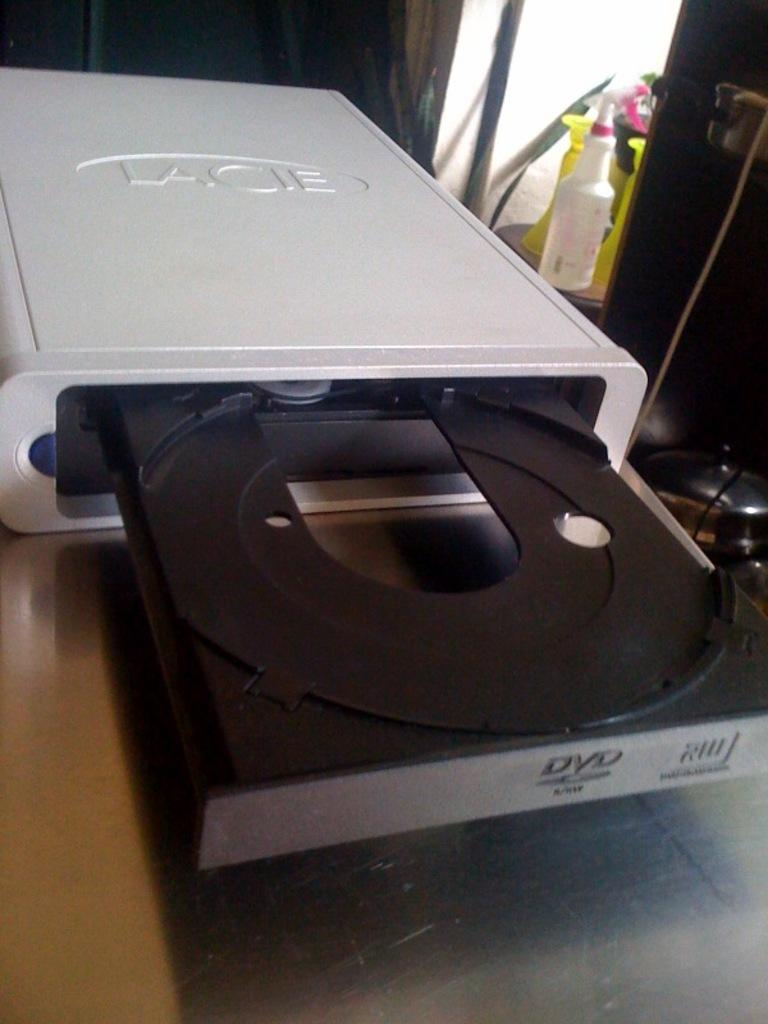<image>
Write a terse but informative summary of the picture. An open dvd player is from the brand Lacie. 